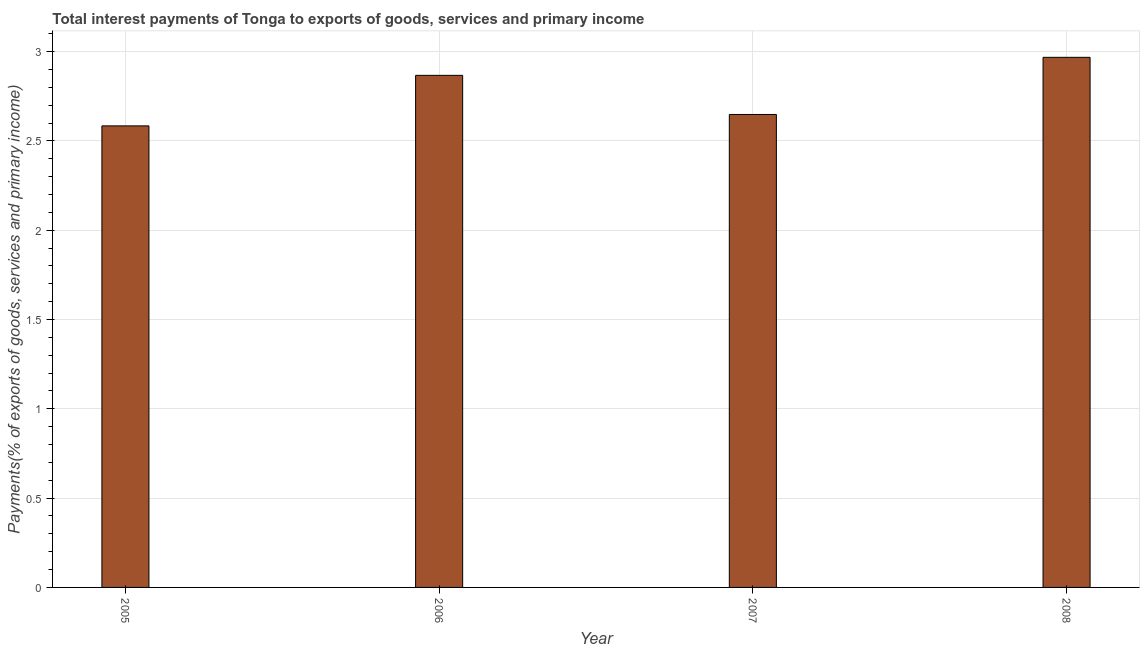Does the graph contain grids?
Your answer should be very brief. Yes. What is the title of the graph?
Your answer should be very brief. Total interest payments of Tonga to exports of goods, services and primary income. What is the label or title of the Y-axis?
Keep it short and to the point. Payments(% of exports of goods, services and primary income). What is the total interest payments on external debt in 2008?
Offer a terse response. 2.97. Across all years, what is the maximum total interest payments on external debt?
Give a very brief answer. 2.97. Across all years, what is the minimum total interest payments on external debt?
Provide a succinct answer. 2.58. What is the sum of the total interest payments on external debt?
Give a very brief answer. 11.07. What is the difference between the total interest payments on external debt in 2007 and 2008?
Make the answer very short. -0.32. What is the average total interest payments on external debt per year?
Keep it short and to the point. 2.77. What is the median total interest payments on external debt?
Your response must be concise. 2.76. In how many years, is the total interest payments on external debt greater than 2.6 %?
Provide a succinct answer. 3. Do a majority of the years between 2008 and 2005 (inclusive) have total interest payments on external debt greater than 3 %?
Keep it short and to the point. Yes. What is the ratio of the total interest payments on external debt in 2006 to that in 2007?
Give a very brief answer. 1.08. Is the total interest payments on external debt in 2007 less than that in 2008?
Your answer should be compact. Yes. What is the difference between the highest and the second highest total interest payments on external debt?
Offer a very short reply. 0.1. What is the difference between the highest and the lowest total interest payments on external debt?
Offer a very short reply. 0.38. In how many years, is the total interest payments on external debt greater than the average total interest payments on external debt taken over all years?
Offer a very short reply. 2. How many years are there in the graph?
Your answer should be compact. 4. Are the values on the major ticks of Y-axis written in scientific E-notation?
Provide a short and direct response. No. What is the Payments(% of exports of goods, services and primary income) of 2005?
Give a very brief answer. 2.58. What is the Payments(% of exports of goods, services and primary income) of 2006?
Ensure brevity in your answer.  2.87. What is the Payments(% of exports of goods, services and primary income) of 2007?
Provide a succinct answer. 2.65. What is the Payments(% of exports of goods, services and primary income) of 2008?
Your answer should be compact. 2.97. What is the difference between the Payments(% of exports of goods, services and primary income) in 2005 and 2006?
Give a very brief answer. -0.28. What is the difference between the Payments(% of exports of goods, services and primary income) in 2005 and 2007?
Offer a terse response. -0.06. What is the difference between the Payments(% of exports of goods, services and primary income) in 2005 and 2008?
Your answer should be very brief. -0.38. What is the difference between the Payments(% of exports of goods, services and primary income) in 2006 and 2007?
Give a very brief answer. 0.22. What is the difference between the Payments(% of exports of goods, services and primary income) in 2006 and 2008?
Offer a very short reply. -0.1. What is the difference between the Payments(% of exports of goods, services and primary income) in 2007 and 2008?
Your answer should be very brief. -0.32. What is the ratio of the Payments(% of exports of goods, services and primary income) in 2005 to that in 2006?
Provide a succinct answer. 0.9. What is the ratio of the Payments(% of exports of goods, services and primary income) in 2005 to that in 2008?
Your answer should be compact. 0.87. What is the ratio of the Payments(% of exports of goods, services and primary income) in 2006 to that in 2007?
Give a very brief answer. 1.08. What is the ratio of the Payments(% of exports of goods, services and primary income) in 2006 to that in 2008?
Ensure brevity in your answer.  0.97. What is the ratio of the Payments(% of exports of goods, services and primary income) in 2007 to that in 2008?
Your answer should be compact. 0.89. 